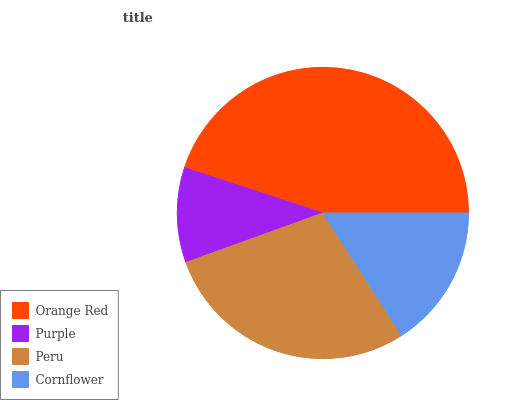Is Purple the minimum?
Answer yes or no. Yes. Is Orange Red the maximum?
Answer yes or no. Yes. Is Peru the minimum?
Answer yes or no. No. Is Peru the maximum?
Answer yes or no. No. Is Peru greater than Purple?
Answer yes or no. Yes. Is Purple less than Peru?
Answer yes or no. Yes. Is Purple greater than Peru?
Answer yes or no. No. Is Peru less than Purple?
Answer yes or no. No. Is Peru the high median?
Answer yes or no. Yes. Is Cornflower the low median?
Answer yes or no. Yes. Is Cornflower the high median?
Answer yes or no. No. Is Peru the low median?
Answer yes or no. No. 